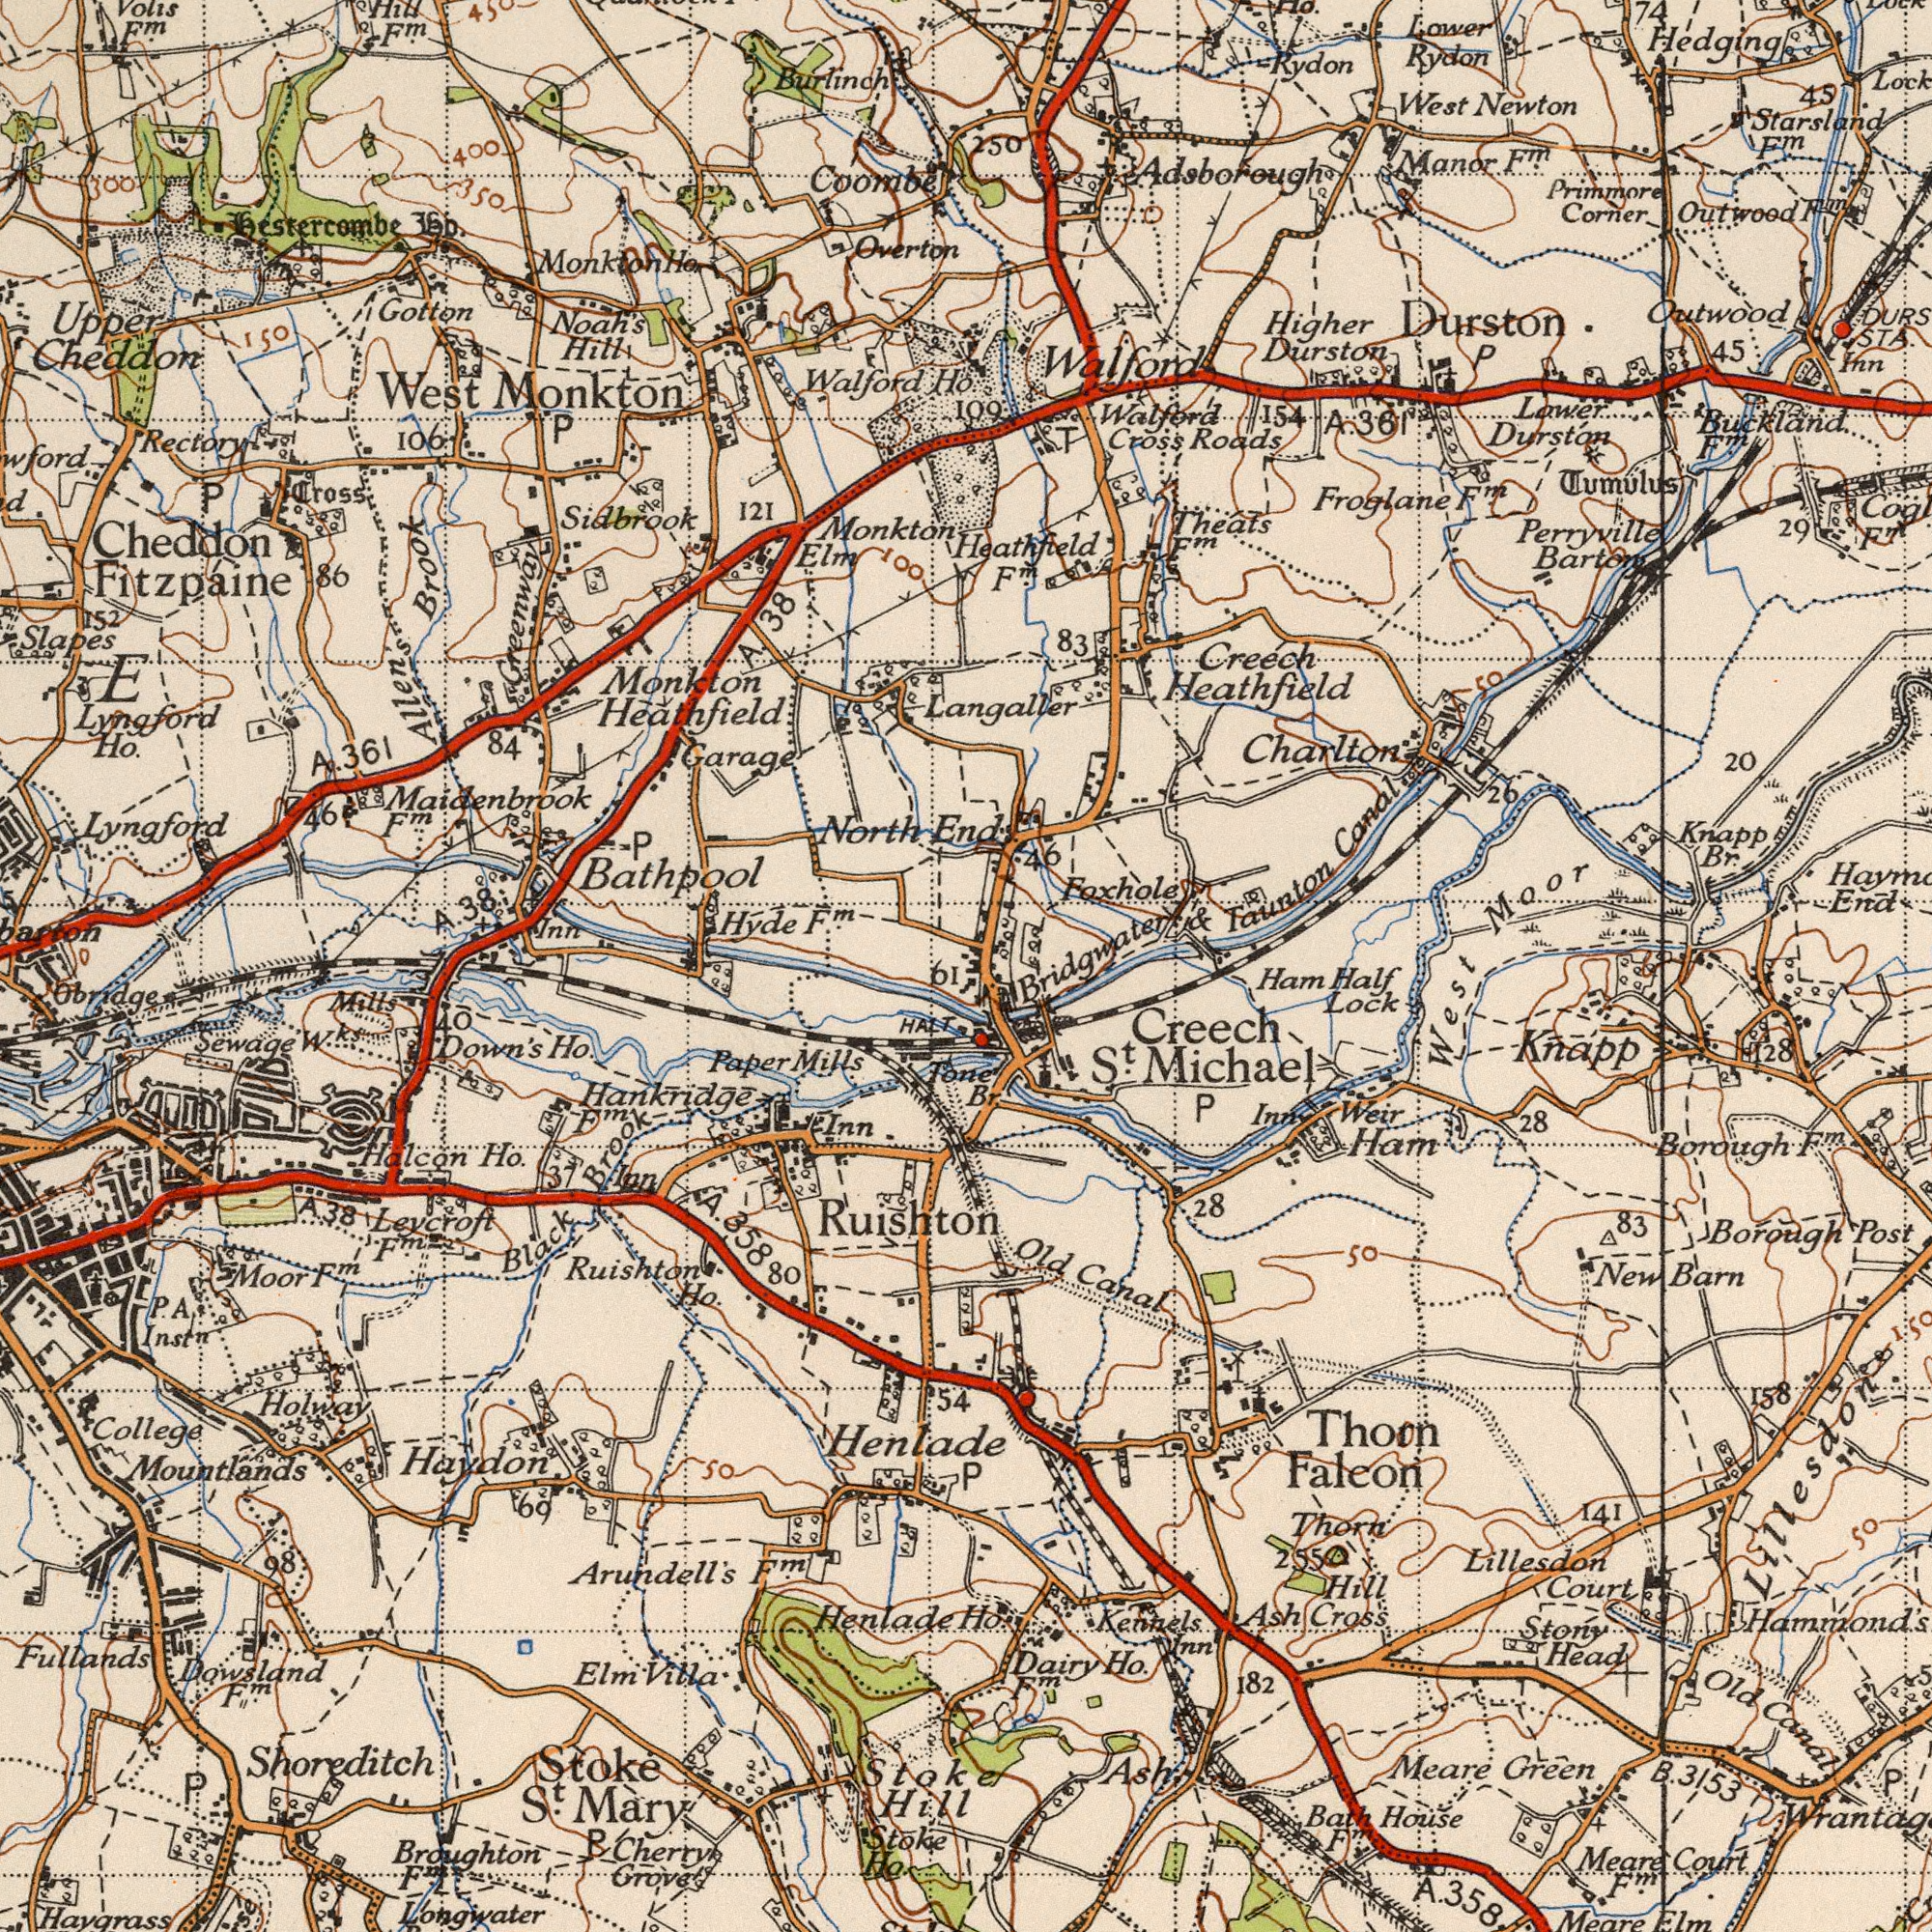What text can you see in the bottom-left section? Henlade Shoreditch Arundell's Haygrass Fullands Mary Hankridge Down's Stoke Ruishton Mountlands Longwater Haydon Ho. Stoke Halcon Black Stoke Ruishton Holway HALT Ho. Hentade Cherry Sewage Broughton Moor Grove Paper Brook Mills S<sup>t</sup>. College Inst<sup>n</sup>. Mills Ho. 37 Obridge Ho. 38 Tone W<sup>ks</sup>. F<sup>m</sup>. A. Inn 61 F<sup>m</sup>. Villa Elm 98 P. Inn 358 F<sup>m</sup>. Hill F<sup>m</sup>. 69 80 50 54 Leycroft P 40 F<sup>m</sup> P F<sup>m</sup>. A. A Dowsland What text appears in the bottom-right area of the image? Borough Lock Michael Borough Falcon Court Knapp 28 Creech Lillesdon Kennels Thorn Green Thorn 3153 358 Stony Ash Ham Barn Canal West House Ash Meare 182 Weir Cross Head Ham S<sup>t</sup>. Post 28 Old Half 83 Meare Dairy Inn 158 Canal Old P Court New Br. 128 50 Meare F<sup>m</sup>. Ho. F<sup>m</sup>. Hill Bath 141 Elm Inn 50 255 Ho. P F<sup>m</sup>. Lillesdon P F<sup>m</sup>. B. A. What text appears in the top-left area of the image? Bathpool Walford Monkton West Upper Lyngford North Cheddon Slapes Hyde Cheddon Overton Monkton Noah's 121 Hill Brook 38 Fitzpaine bo. Cross E Lyngford Monkton Ho. 38 Elm 106 152 86 Ho. Garage Greenway Gotton Coombe Inn Allen's Burlinch P Volis Monkton F<sup>m</sup>. F<sup>m</sup>. Rectory P 84 Sidbrook Hestercombe A. F<sup>m</sup>. P Hill 150 100 361 400 Maidenbrook 350 450 46 Ho. Heathfield 300 A. F<sup>m</sup>. A. What text appears in the top-right area of the image? End Starsland Manor Durston Creech Durston. Charlton Froglane Roads Outwood West Taunton Durston Corner Higher Primmore STA. Newton Theats Rydon Lower Hedging End Knapp Outwood Br. 45 Lower Perryville 361 Langaller Rydon Barton Heathfield 45 20 F<sup>m</sup>. Heathfield 83 Tumulus 250 T Foxhole Moor 29 F<sup>m</sup>. 154 Buckland F<sup>m</sup>. Inn 74 Adsborough F<sup>m</sup>. 109 Walford F<sup>m</sup>. Canal 46 Bridgwater F<sup>m</sup>. Cross F<sup>m</sup>. Walford 26 F<sup>m</sup>. P A. & 